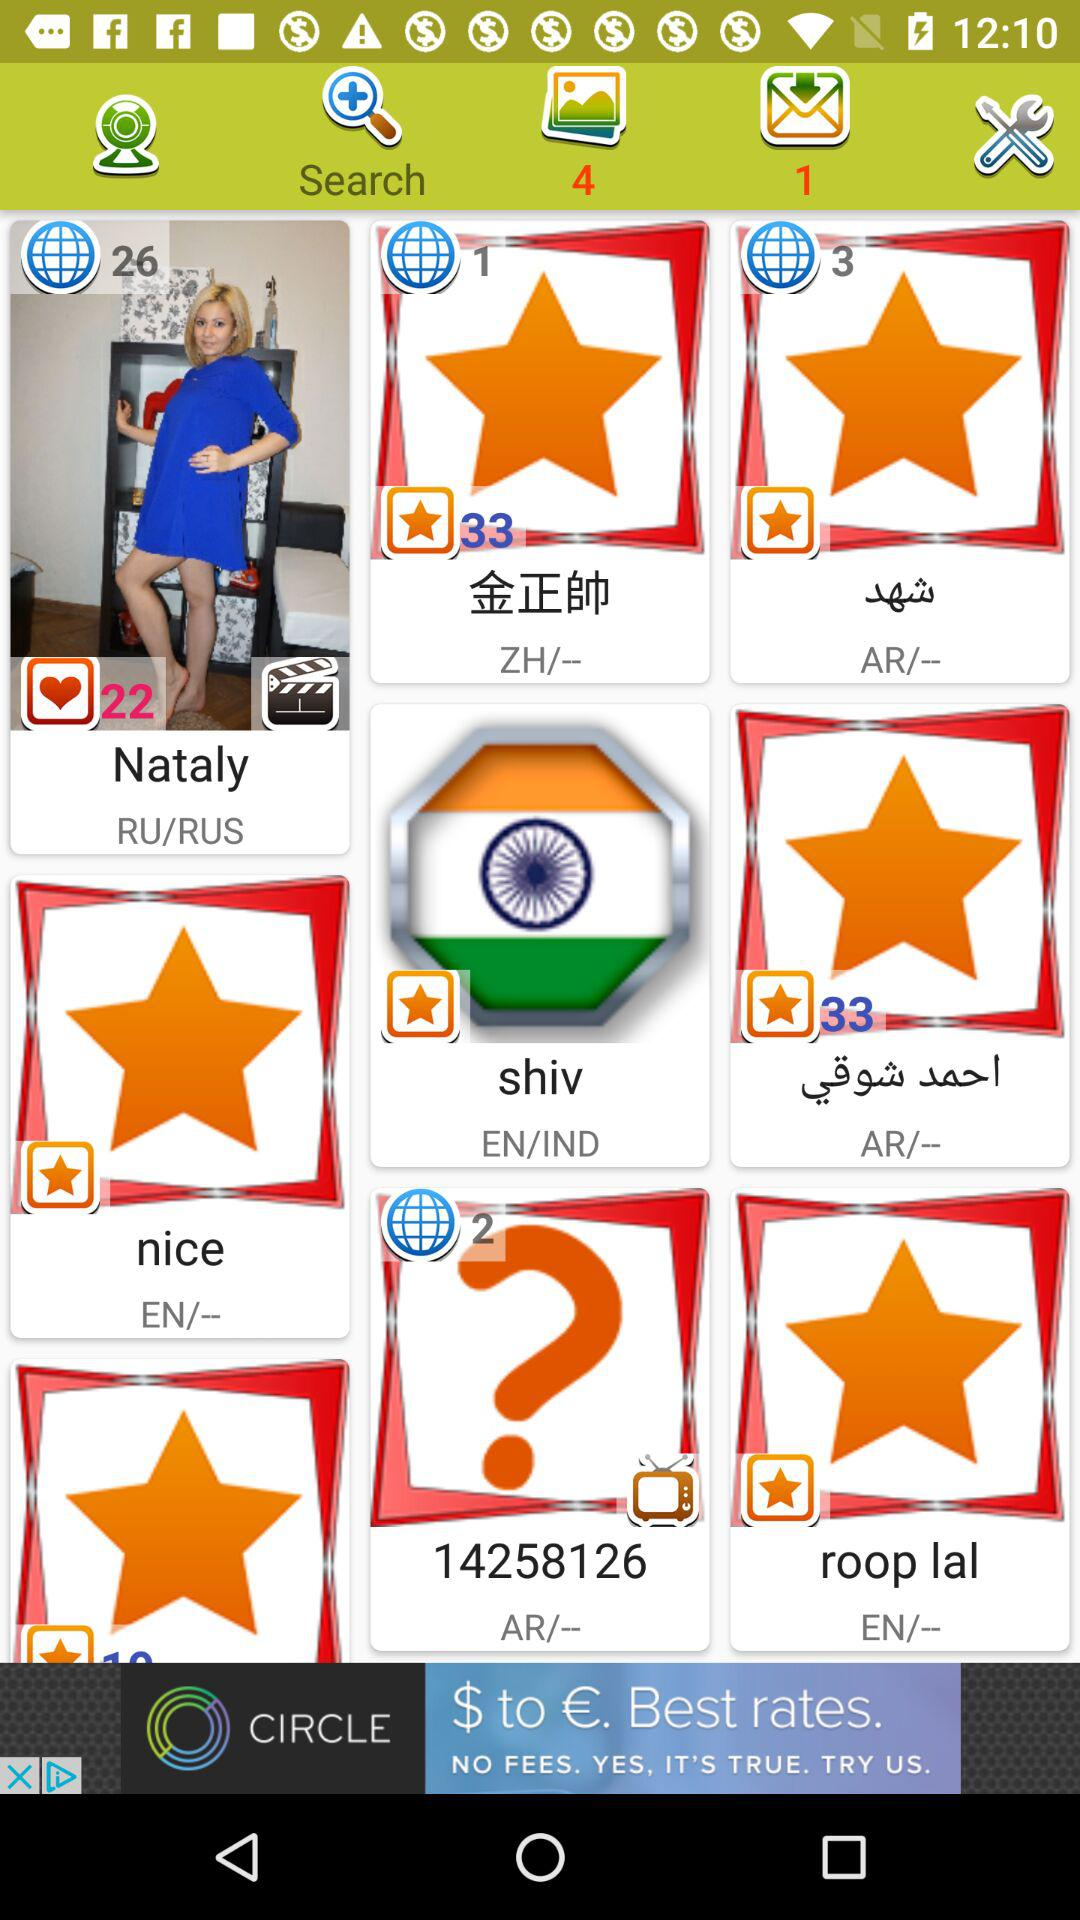How many likes are there of Nataly? There are 22 likes. 